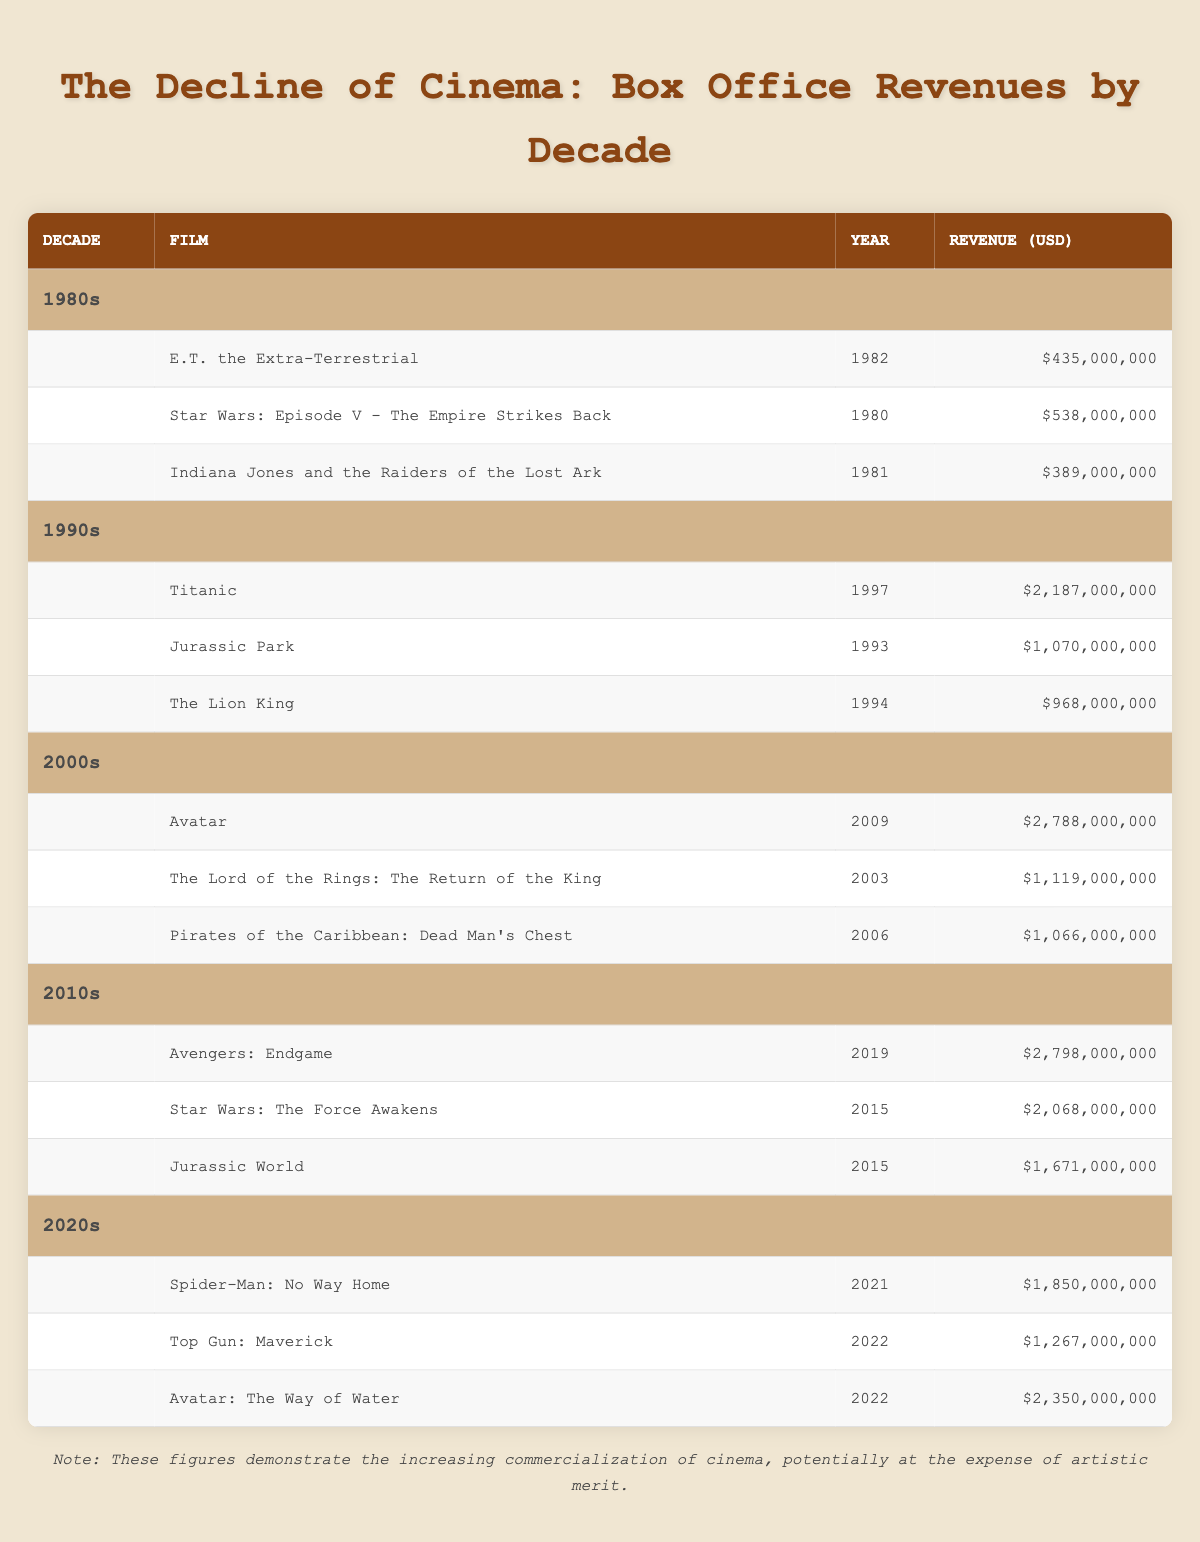What was the highest-grossing film of the 1990s? The highest-grossing film in the 1990s is "Titanic," released in 1997 with a revenue of 2,187,000,000. This information can be found directly by looking at the "1990s" section of the table.
Answer: Titanic How much revenue did "Avatar" earn in its release year? "Avatar" earned 2,788,000,000 in 2009. This value is directly stated in the 2000s section of the table for the film listed under that year.
Answer: 2,788,000,000 What is the total box office revenue of the top three films from the 1980s? The total revenue would be calculated by adding the revenues of the three films: E.T. (435,000,000) + Star Wars: Episode V (538,000,000) + Indiana Jones (389,000,000). Summing these gives 435 + 538 + 389 = 1,362,000,000.
Answer: 1,362,000,000 Is "Jurassic Park" the only film from the 1990s that earned over 1 billion USD? No, "Jurassic Park" is not the only film from the 1990s that earned over 1 billion USD. "Titanic" and "The Lion King" also earned more than 1 billion. This can be confirmed by checking the revenue figures in the 1990s section of the table and noting the values for each film.
Answer: No Which decade produced more films with revenues exceeding 2 billion USD? The 2010s decade produced more films with revenues exceeding 2 billion USD. The films "Avengers: Endgame" and "Star Wars: The Force Awakens" from that decade each crossed that threshold, whereas in the 2000s, only "Avatar" exceeded 2 billion. A look at the individual revenues of films in each decade confirms this finding.
Answer: 2010s What is the average revenue of the films listed from the 2020s? To find the average revenue for the 2020s films, first sum the revenues: Spider-Man: No Way Home (1,850,000,000) + Top Gun: Maverick (1,267,000,000) + Avatar: The Way of Water (2,350,000,000). The total revenue is 1,850,000,000 + 1,267,000,000 + 2,350,000,000 = 5,467,000,000. There are three films, so dividing gives an average of 5,467,000,000 / 3 = 1,822,333,333.33.
Answer: 1,822,333,333.33 Did any films in the 1980s earn more than 500 million USD? No, none of the films from the 1980s earned more than 500 million USD. The highest earning film, "Star Wars: Episode V," earned 538,000,000, which is the only figure in that decade above 400 million but still below 500 million. By checking the revenues of all 1980s films in the table, this can be verified.
Answer: No Which film had the highest box office revenue in the 2010s? "Avengers: Endgame" had the highest box office revenue in the 2010s, earning 2,798,000,000. This information is easily accessible by observing the 2010s section of the table and finding the individual film revenues listed.
Answer: Avengers: Endgame 